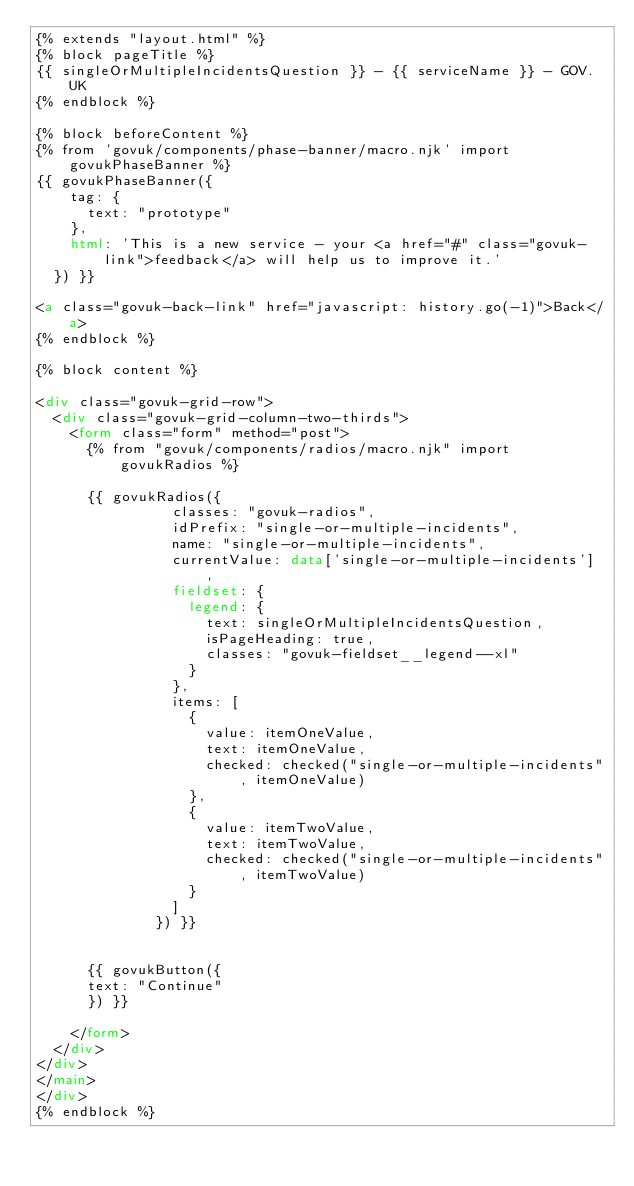Convert code to text. <code><loc_0><loc_0><loc_500><loc_500><_HTML_>{% extends "layout.html" %}
{% block pageTitle %}
{{ singleOrMultipleIncidentsQuestion }} - {{ serviceName }} - GOV.UK
{% endblock %}

{% block beforeContent %}
{% from 'govuk/components/phase-banner/macro.njk' import govukPhaseBanner %}
{{ govukPhaseBanner({
    tag: {
      text: "prototype"
    },
    html: 'This is a new service - your <a href="#" class="govuk-link">feedback</a> will help us to improve it.'
  }) }}

<a class="govuk-back-link" href="javascript: history.go(-1)">Back</a>
{% endblock %}

{% block content %}

<div class="govuk-grid-row">
  <div class="govuk-grid-column-two-thirds">
    <form class="form" method="post">
      {% from "govuk/components/radios/macro.njk" import govukRadios %}

      {{ govukRadios({
                classes: "govuk-radios",
                idPrefix: "single-or-multiple-incidents",
                name: "single-or-multiple-incidents",
                currentValue: data['single-or-multiple-incidents'] ,
                fieldset: {
                  legend: {
                    text: singleOrMultipleIncidentsQuestion,
                    isPageHeading: true,
                    classes: "govuk-fieldset__legend--xl"
                  }
                },
                items: [
                  {
                    value: itemOneValue,
                    text: itemOneValue,
                    checked: checked("single-or-multiple-incidents", itemOneValue)
                  },
                  {
                    value: itemTwoValue,
                    text: itemTwoValue,
                    checked: checked("single-or-multiple-incidents", itemTwoValue)
                  }
                ]
              }) }}

      
      {{ govukButton({
      text: "Continue"
      }) }}

    </form>
  </div>
</div>
</main>
</div>
{% endblock %}
</code> 